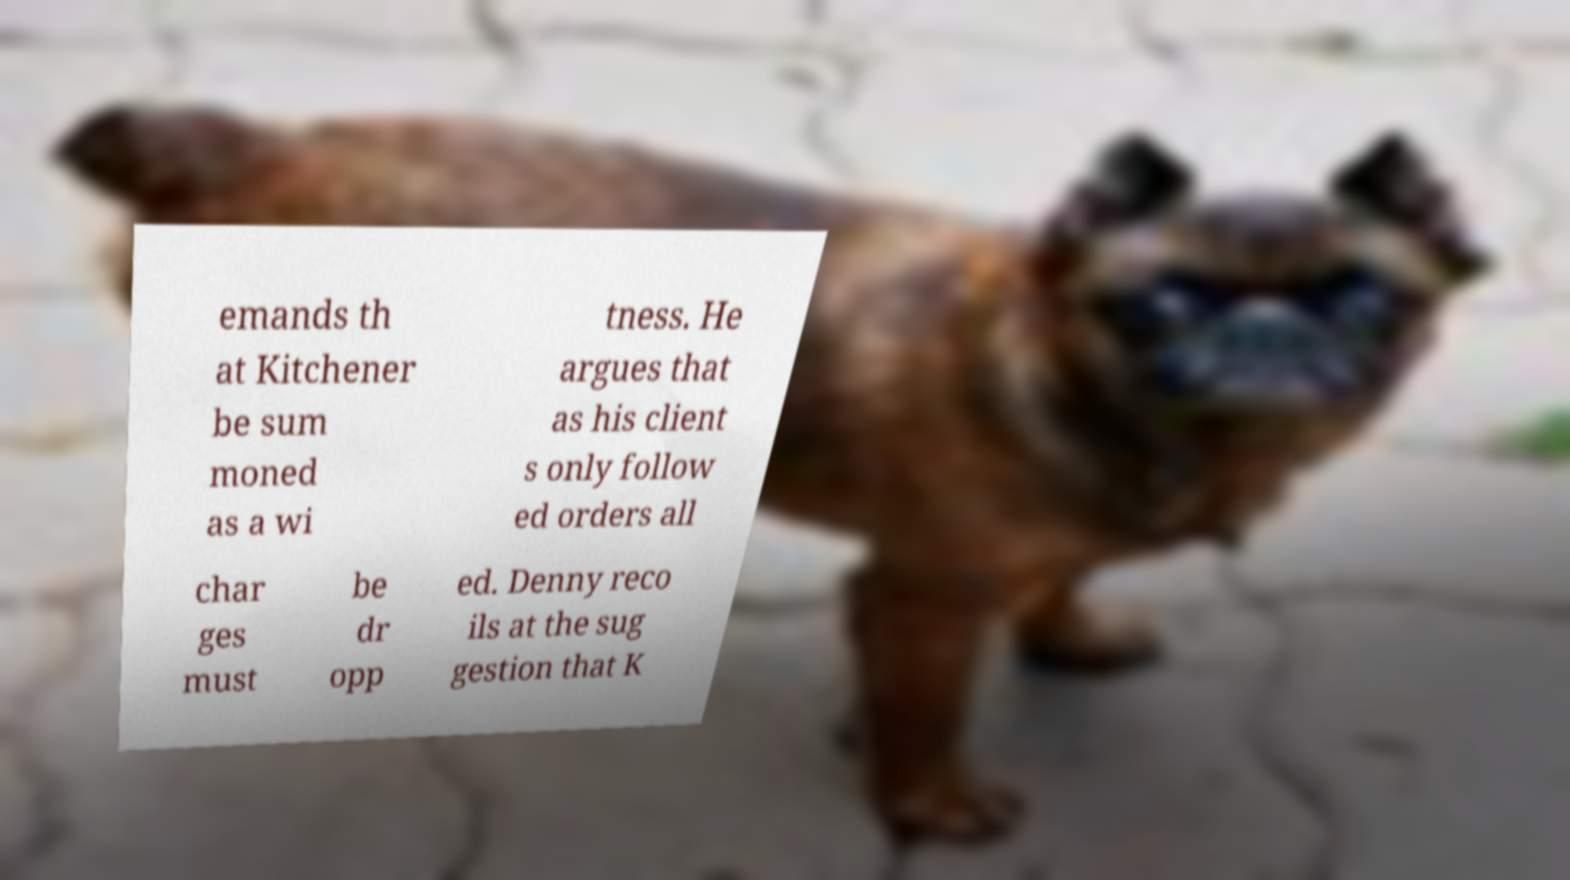I need the written content from this picture converted into text. Can you do that? emands th at Kitchener be sum moned as a wi tness. He argues that as his client s only follow ed orders all char ges must be dr opp ed. Denny reco ils at the sug gestion that K 